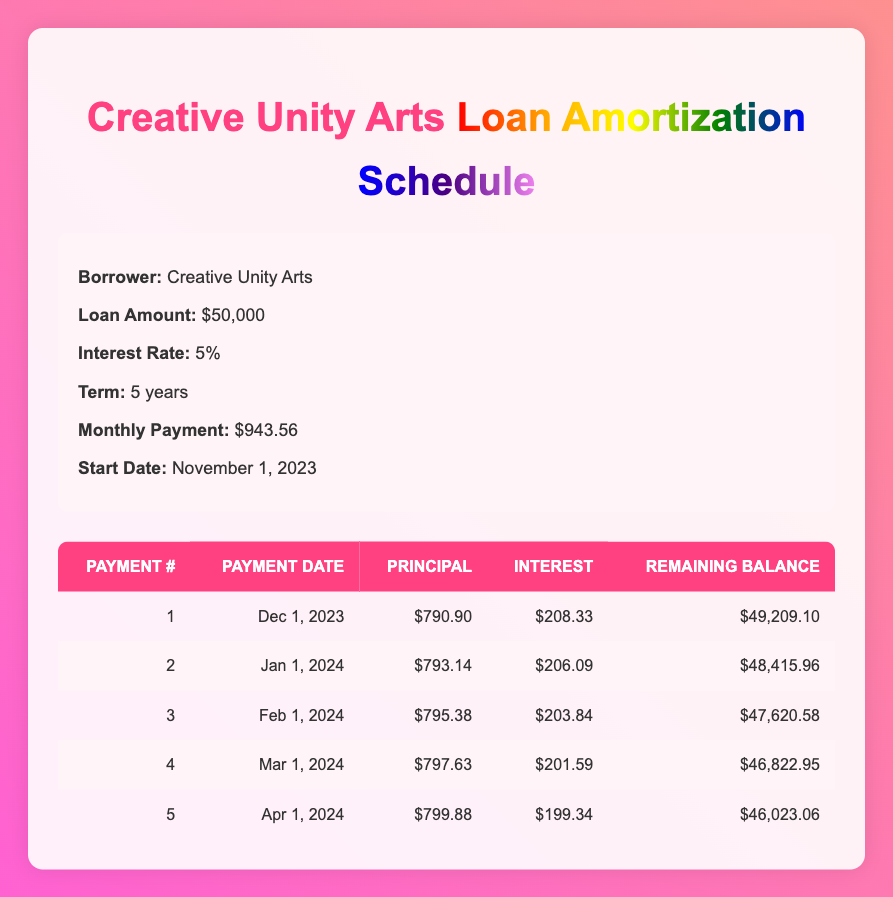What is the total amount of principal paid in the first five payments? To find the total principal paid, we need to sum the principal payments from the first five rows of the table: 790.90 + 793.14 + 795.38 + 797.63 + 799.88 = 3977.93
Answer: 3977.93 What is the remaining balance after the first payment? The remaining balance after the first payment is listed directly in the table in the first row: 49,209.10.
Answer: 49,209.10 Is the monthly payment constant throughout the loan term? Yes, the monthly payment of $943.56 is the same for each month as indicated in the details section of the table.
Answer: Yes Which payment has the highest principal payment amount? From the table, the highest principal payment is in the fifth payment amounting to $799.88.
Answer: $799.88 What is the total interest paid in the first three payments? To find the total interest paid in the first three payments, we sum the interest payments from the first three rows: 208.33 + 206.09 + 203.84 = 618.26.
Answer: 618.26 What is the average principal payment over the first five payments? The average principal payment is calculated by summing the principal payments (790.90 + 793.14 + 795.38 + 797.63 + 799.88 = 3977.93) and dividing by 5: 3977.93 / 5 = 795.586.
Answer: 795.586 Is the interest payment decreasing with each subsequent payment? Yes, observing the interest payments in the table shows a decreasing trend: 208.33, 206.09, 203.84, 201.59, and 199.34.
Answer: Yes What is the total loan amount minus the remaining balance after the second payment? The total loan amount is $50,000. The remaining balance after the second payment is $48,415.96. Hence, we subtract these two amounts: $50,000 - $48,415.96 = $1,584.04.
Answer: $1,584.04 